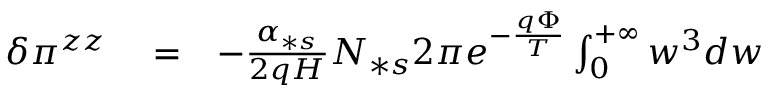Convert formula to latex. <formula><loc_0><loc_0><loc_500><loc_500>\begin{array} { r l r } { \delta \pi ^ { z z } } & = } & { - \frac { \alpha _ { \ast s } } { 2 q H } N _ { \ast s } 2 \pi e ^ { - \frac { q \Phi } { T } } \int _ { 0 } ^ { + \infty } w ^ { 3 } d w } \end{array}</formula> 